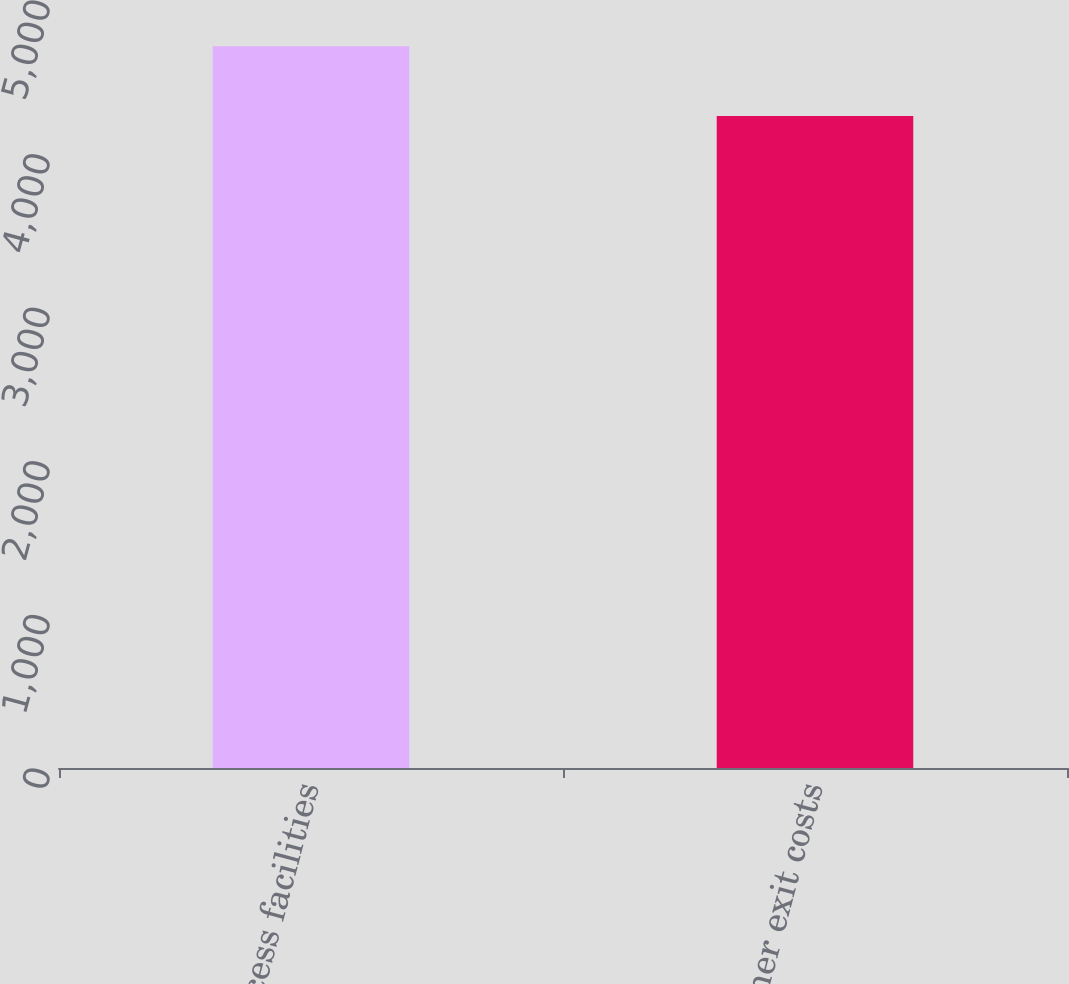<chart> <loc_0><loc_0><loc_500><loc_500><bar_chart><fcel>Excess facilities<fcel>Other exit costs<nl><fcel>4699<fcel>4244<nl></chart> 